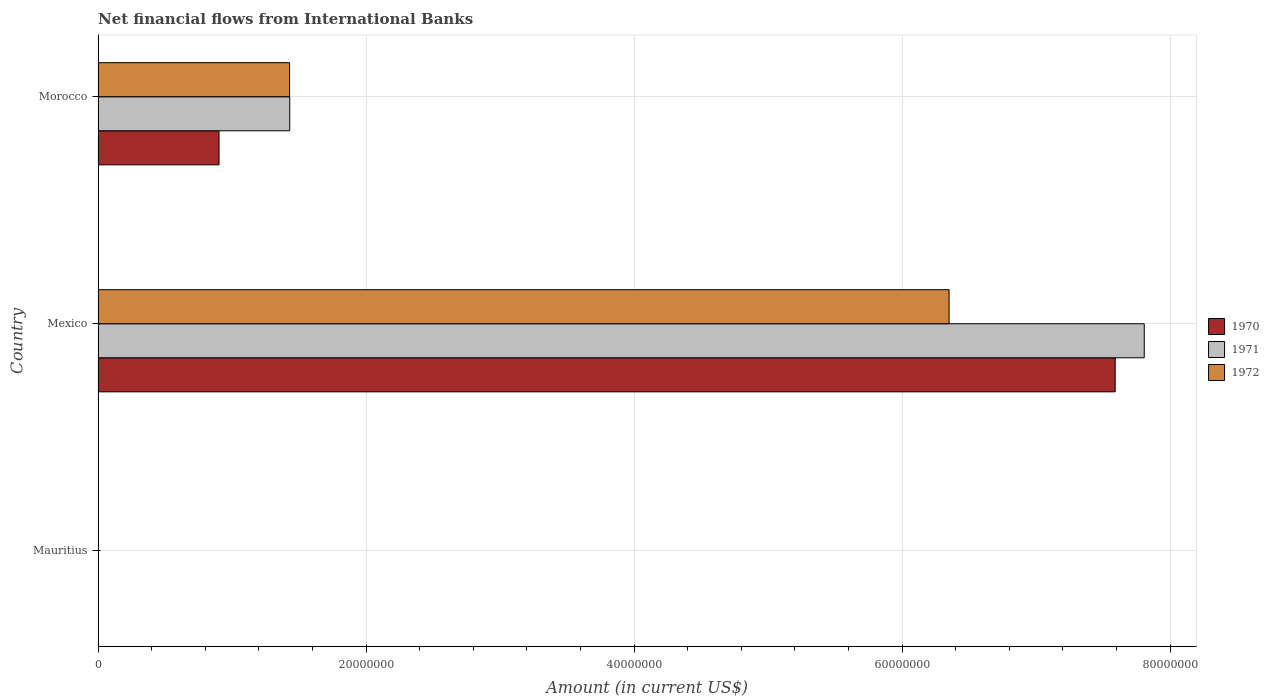Are the number of bars on each tick of the Y-axis equal?
Keep it short and to the point. No. How many bars are there on the 3rd tick from the top?
Your answer should be very brief. 0. How many bars are there on the 2nd tick from the bottom?
Keep it short and to the point. 3. In how many cases, is the number of bars for a given country not equal to the number of legend labels?
Keep it short and to the point. 1. What is the net financial aid flows in 1971 in Mexico?
Offer a terse response. 7.81e+07. Across all countries, what is the maximum net financial aid flows in 1970?
Your response must be concise. 7.59e+07. Across all countries, what is the minimum net financial aid flows in 1970?
Provide a short and direct response. 0. In which country was the net financial aid flows in 1971 maximum?
Your answer should be very brief. Mexico. What is the total net financial aid flows in 1972 in the graph?
Your response must be concise. 7.78e+07. What is the difference between the net financial aid flows in 1970 in Mexico and that in Morocco?
Your answer should be compact. 6.69e+07. What is the difference between the net financial aid flows in 1971 in Morocco and the net financial aid flows in 1972 in Mexico?
Offer a very short reply. -4.92e+07. What is the average net financial aid flows in 1971 per country?
Your answer should be very brief. 3.08e+07. What is the difference between the net financial aid flows in 1970 and net financial aid flows in 1972 in Mexico?
Your response must be concise. 1.24e+07. In how many countries, is the net financial aid flows in 1970 greater than 60000000 US$?
Give a very brief answer. 1. What is the ratio of the net financial aid flows in 1970 in Mexico to that in Morocco?
Your answer should be very brief. 8.41. What is the difference between the highest and the lowest net financial aid flows in 1970?
Your answer should be very brief. 7.59e+07. Is the sum of the net financial aid flows in 1970 in Mexico and Morocco greater than the maximum net financial aid flows in 1972 across all countries?
Give a very brief answer. Yes. Are all the bars in the graph horizontal?
Offer a terse response. Yes. How many countries are there in the graph?
Ensure brevity in your answer.  3. Are the values on the major ticks of X-axis written in scientific E-notation?
Give a very brief answer. No. Does the graph contain any zero values?
Provide a short and direct response. Yes. How many legend labels are there?
Make the answer very short. 3. How are the legend labels stacked?
Provide a short and direct response. Vertical. What is the title of the graph?
Ensure brevity in your answer.  Net financial flows from International Banks. What is the label or title of the X-axis?
Provide a short and direct response. Amount (in current US$). What is the label or title of the Y-axis?
Make the answer very short. Country. What is the Amount (in current US$) of 1971 in Mauritius?
Offer a terse response. 0. What is the Amount (in current US$) of 1972 in Mauritius?
Ensure brevity in your answer.  0. What is the Amount (in current US$) in 1970 in Mexico?
Give a very brief answer. 7.59e+07. What is the Amount (in current US$) of 1971 in Mexico?
Your response must be concise. 7.81e+07. What is the Amount (in current US$) of 1972 in Mexico?
Provide a succinct answer. 6.35e+07. What is the Amount (in current US$) in 1970 in Morocco?
Offer a terse response. 9.03e+06. What is the Amount (in current US$) of 1971 in Morocco?
Your response must be concise. 1.43e+07. What is the Amount (in current US$) in 1972 in Morocco?
Your answer should be compact. 1.43e+07. Across all countries, what is the maximum Amount (in current US$) in 1970?
Your answer should be compact. 7.59e+07. Across all countries, what is the maximum Amount (in current US$) of 1971?
Ensure brevity in your answer.  7.81e+07. Across all countries, what is the maximum Amount (in current US$) of 1972?
Your answer should be compact. 6.35e+07. Across all countries, what is the minimum Amount (in current US$) of 1972?
Make the answer very short. 0. What is the total Amount (in current US$) of 1970 in the graph?
Offer a very short reply. 8.49e+07. What is the total Amount (in current US$) of 1971 in the graph?
Give a very brief answer. 9.24e+07. What is the total Amount (in current US$) of 1972 in the graph?
Ensure brevity in your answer.  7.78e+07. What is the difference between the Amount (in current US$) of 1970 in Mexico and that in Morocco?
Your response must be concise. 6.69e+07. What is the difference between the Amount (in current US$) of 1971 in Mexico and that in Morocco?
Make the answer very short. 6.38e+07. What is the difference between the Amount (in current US$) in 1972 in Mexico and that in Morocco?
Your answer should be compact. 4.92e+07. What is the difference between the Amount (in current US$) in 1970 in Mexico and the Amount (in current US$) in 1971 in Morocco?
Your answer should be very brief. 6.16e+07. What is the difference between the Amount (in current US$) in 1970 in Mexico and the Amount (in current US$) in 1972 in Morocco?
Make the answer very short. 6.16e+07. What is the difference between the Amount (in current US$) of 1971 in Mexico and the Amount (in current US$) of 1972 in Morocco?
Give a very brief answer. 6.38e+07. What is the average Amount (in current US$) in 1970 per country?
Offer a terse response. 2.83e+07. What is the average Amount (in current US$) in 1971 per country?
Your answer should be very brief. 3.08e+07. What is the average Amount (in current US$) in 1972 per country?
Provide a succinct answer. 2.59e+07. What is the difference between the Amount (in current US$) of 1970 and Amount (in current US$) of 1971 in Mexico?
Offer a terse response. -2.17e+06. What is the difference between the Amount (in current US$) in 1970 and Amount (in current US$) in 1972 in Mexico?
Ensure brevity in your answer.  1.24e+07. What is the difference between the Amount (in current US$) of 1971 and Amount (in current US$) of 1972 in Mexico?
Give a very brief answer. 1.46e+07. What is the difference between the Amount (in current US$) in 1970 and Amount (in current US$) in 1971 in Morocco?
Provide a succinct answer. -5.28e+06. What is the difference between the Amount (in current US$) of 1970 and Amount (in current US$) of 1972 in Morocco?
Give a very brief answer. -5.27e+06. What is the ratio of the Amount (in current US$) of 1970 in Mexico to that in Morocco?
Provide a short and direct response. 8.41. What is the ratio of the Amount (in current US$) of 1971 in Mexico to that in Morocco?
Your response must be concise. 5.46. What is the ratio of the Amount (in current US$) of 1972 in Mexico to that in Morocco?
Ensure brevity in your answer.  4.44. What is the difference between the highest and the lowest Amount (in current US$) in 1970?
Your answer should be compact. 7.59e+07. What is the difference between the highest and the lowest Amount (in current US$) of 1971?
Your answer should be very brief. 7.81e+07. What is the difference between the highest and the lowest Amount (in current US$) in 1972?
Provide a short and direct response. 6.35e+07. 